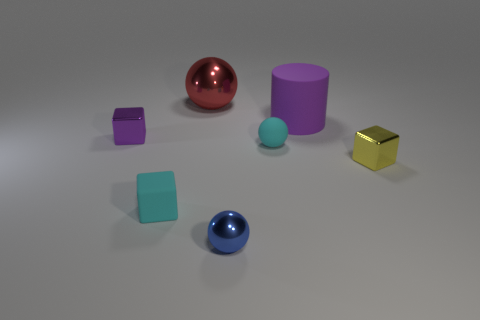Is there any other thing that is the same size as the red metallic sphere?
Ensure brevity in your answer.  Yes. How many other objects are there of the same size as the blue shiny ball?
Make the answer very short. 4. What shape is the thing in front of the cube that is in front of the small yellow object right of the tiny cyan sphere?
Your answer should be compact. Sphere. What shape is the small metal thing that is in front of the cyan rubber sphere and left of the yellow metal object?
Provide a short and direct response. Sphere. How many things are either small cyan matte objects or metal cubes that are on the right side of the large purple cylinder?
Ensure brevity in your answer.  3. Are the red ball and the purple cylinder made of the same material?
Make the answer very short. No. How many other objects are the same shape as the red shiny object?
Give a very brief answer. 2. There is a matte thing that is behind the tiny yellow cube and left of the big purple matte cylinder; how big is it?
Make the answer very short. Small. How many rubber things are blocks or brown cylinders?
Provide a succinct answer. 1. Does the purple object on the left side of the purple matte object have the same shape as the cyan rubber object on the left side of the small cyan sphere?
Offer a very short reply. Yes. 